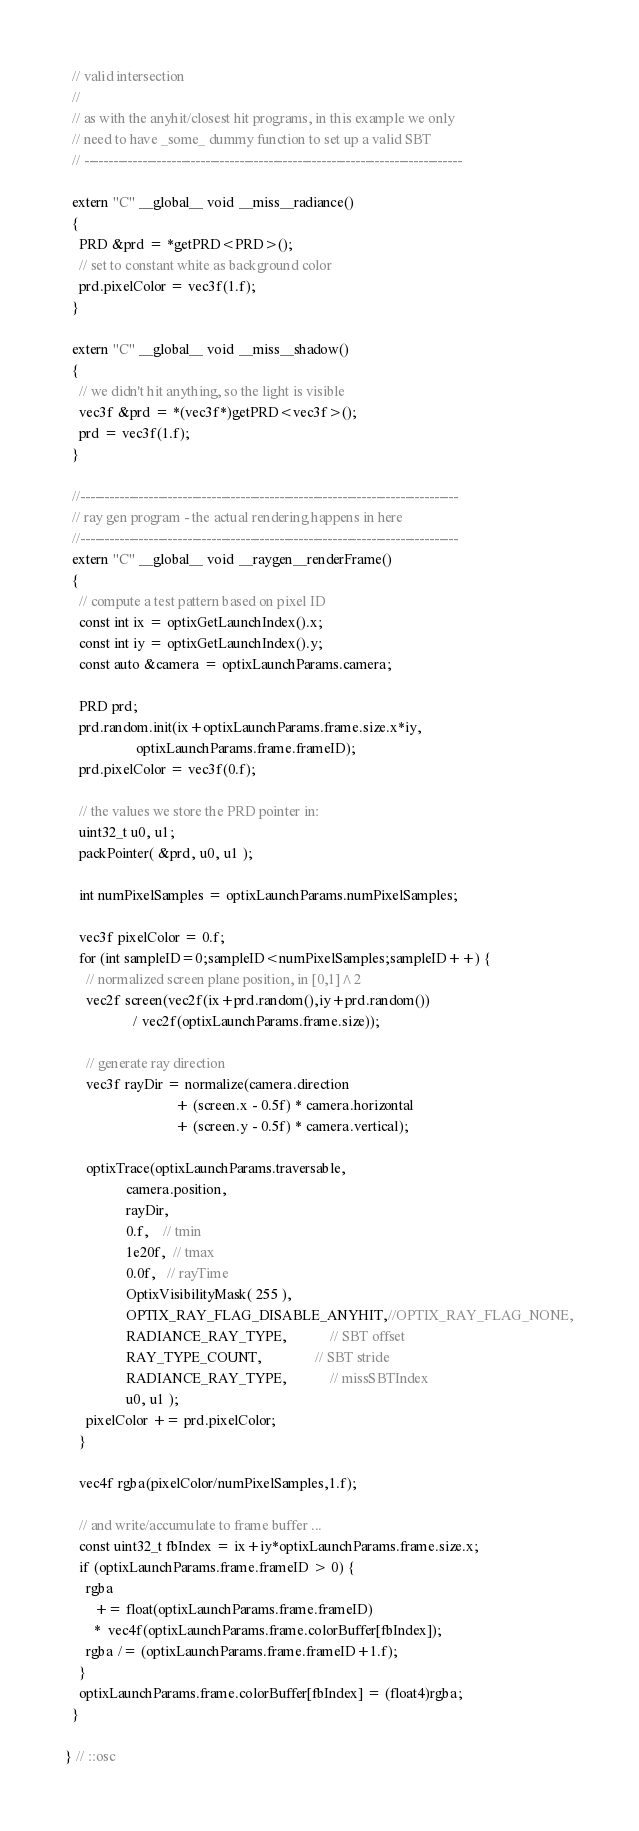<code> <loc_0><loc_0><loc_500><loc_500><_Cuda_>  // valid intersection
  //
  // as with the anyhit/closest hit programs, in this example we only
  // need to have _some_ dummy function to set up a valid SBT
  // ------------------------------------------------------------------------------
  
  extern "C" __global__ void __miss__radiance()
  {
    PRD &prd = *getPRD<PRD>();
    // set to constant white as background color
    prd.pixelColor = vec3f(1.f);
  }

  extern "C" __global__ void __miss__shadow()
  {
    // we didn't hit anything, so the light is visible
    vec3f &prd = *(vec3f*)getPRD<vec3f>();
    prd = vec3f(1.f);
  }

  //------------------------------------------------------------------------------
  // ray gen program - the actual rendering happens in here
  //------------------------------------------------------------------------------
  extern "C" __global__ void __raygen__renderFrame()
  {
    // compute a test pattern based on pixel ID
    const int ix = optixGetLaunchIndex().x;
    const int iy = optixGetLaunchIndex().y;
    const auto &camera = optixLaunchParams.camera;
    
    PRD prd;
    prd.random.init(ix+optixLaunchParams.frame.size.x*iy,
                    optixLaunchParams.frame.frameID);
    prd.pixelColor = vec3f(0.f);

    // the values we store the PRD pointer in:
    uint32_t u0, u1;
    packPointer( &prd, u0, u1 );

    int numPixelSamples = optixLaunchParams.numPixelSamples;

    vec3f pixelColor = 0.f;
    for (int sampleID=0;sampleID<numPixelSamples;sampleID++) {
      // normalized screen plane position, in [0,1]^2
      vec2f screen(vec2f(ix+prd.random(),iy+prd.random())
                   / vec2f(optixLaunchParams.frame.size));
      
      // generate ray direction
      vec3f rayDir = normalize(camera.direction
                               + (screen.x - 0.5f) * camera.horizontal
                               + (screen.y - 0.5f) * camera.vertical);

      optixTrace(optixLaunchParams.traversable,
                 camera.position,
                 rayDir,
                 0.f,    // tmin
                 1e20f,  // tmax
                 0.0f,   // rayTime
                 OptixVisibilityMask( 255 ),
                 OPTIX_RAY_FLAG_DISABLE_ANYHIT,//OPTIX_RAY_FLAG_NONE,
                 RADIANCE_RAY_TYPE,            // SBT offset
                 RAY_TYPE_COUNT,               // SBT stride
                 RADIANCE_RAY_TYPE,            // missSBTIndex 
                 u0, u1 );
      pixelColor += prd.pixelColor;
    }

    vec4f rgba(pixelColor/numPixelSamples,1.f);

    // and write/accumulate to frame buffer ...
    const uint32_t fbIndex = ix+iy*optixLaunchParams.frame.size.x;
    if (optixLaunchParams.frame.frameID > 0) {
      rgba
        += float(optixLaunchParams.frame.frameID)
        *  vec4f(optixLaunchParams.frame.colorBuffer[fbIndex]);
      rgba /= (optixLaunchParams.frame.frameID+1.f);
    }
    optixLaunchParams.frame.colorBuffer[fbIndex] = (float4)rgba;
  }
  
} // ::osc
</code> 